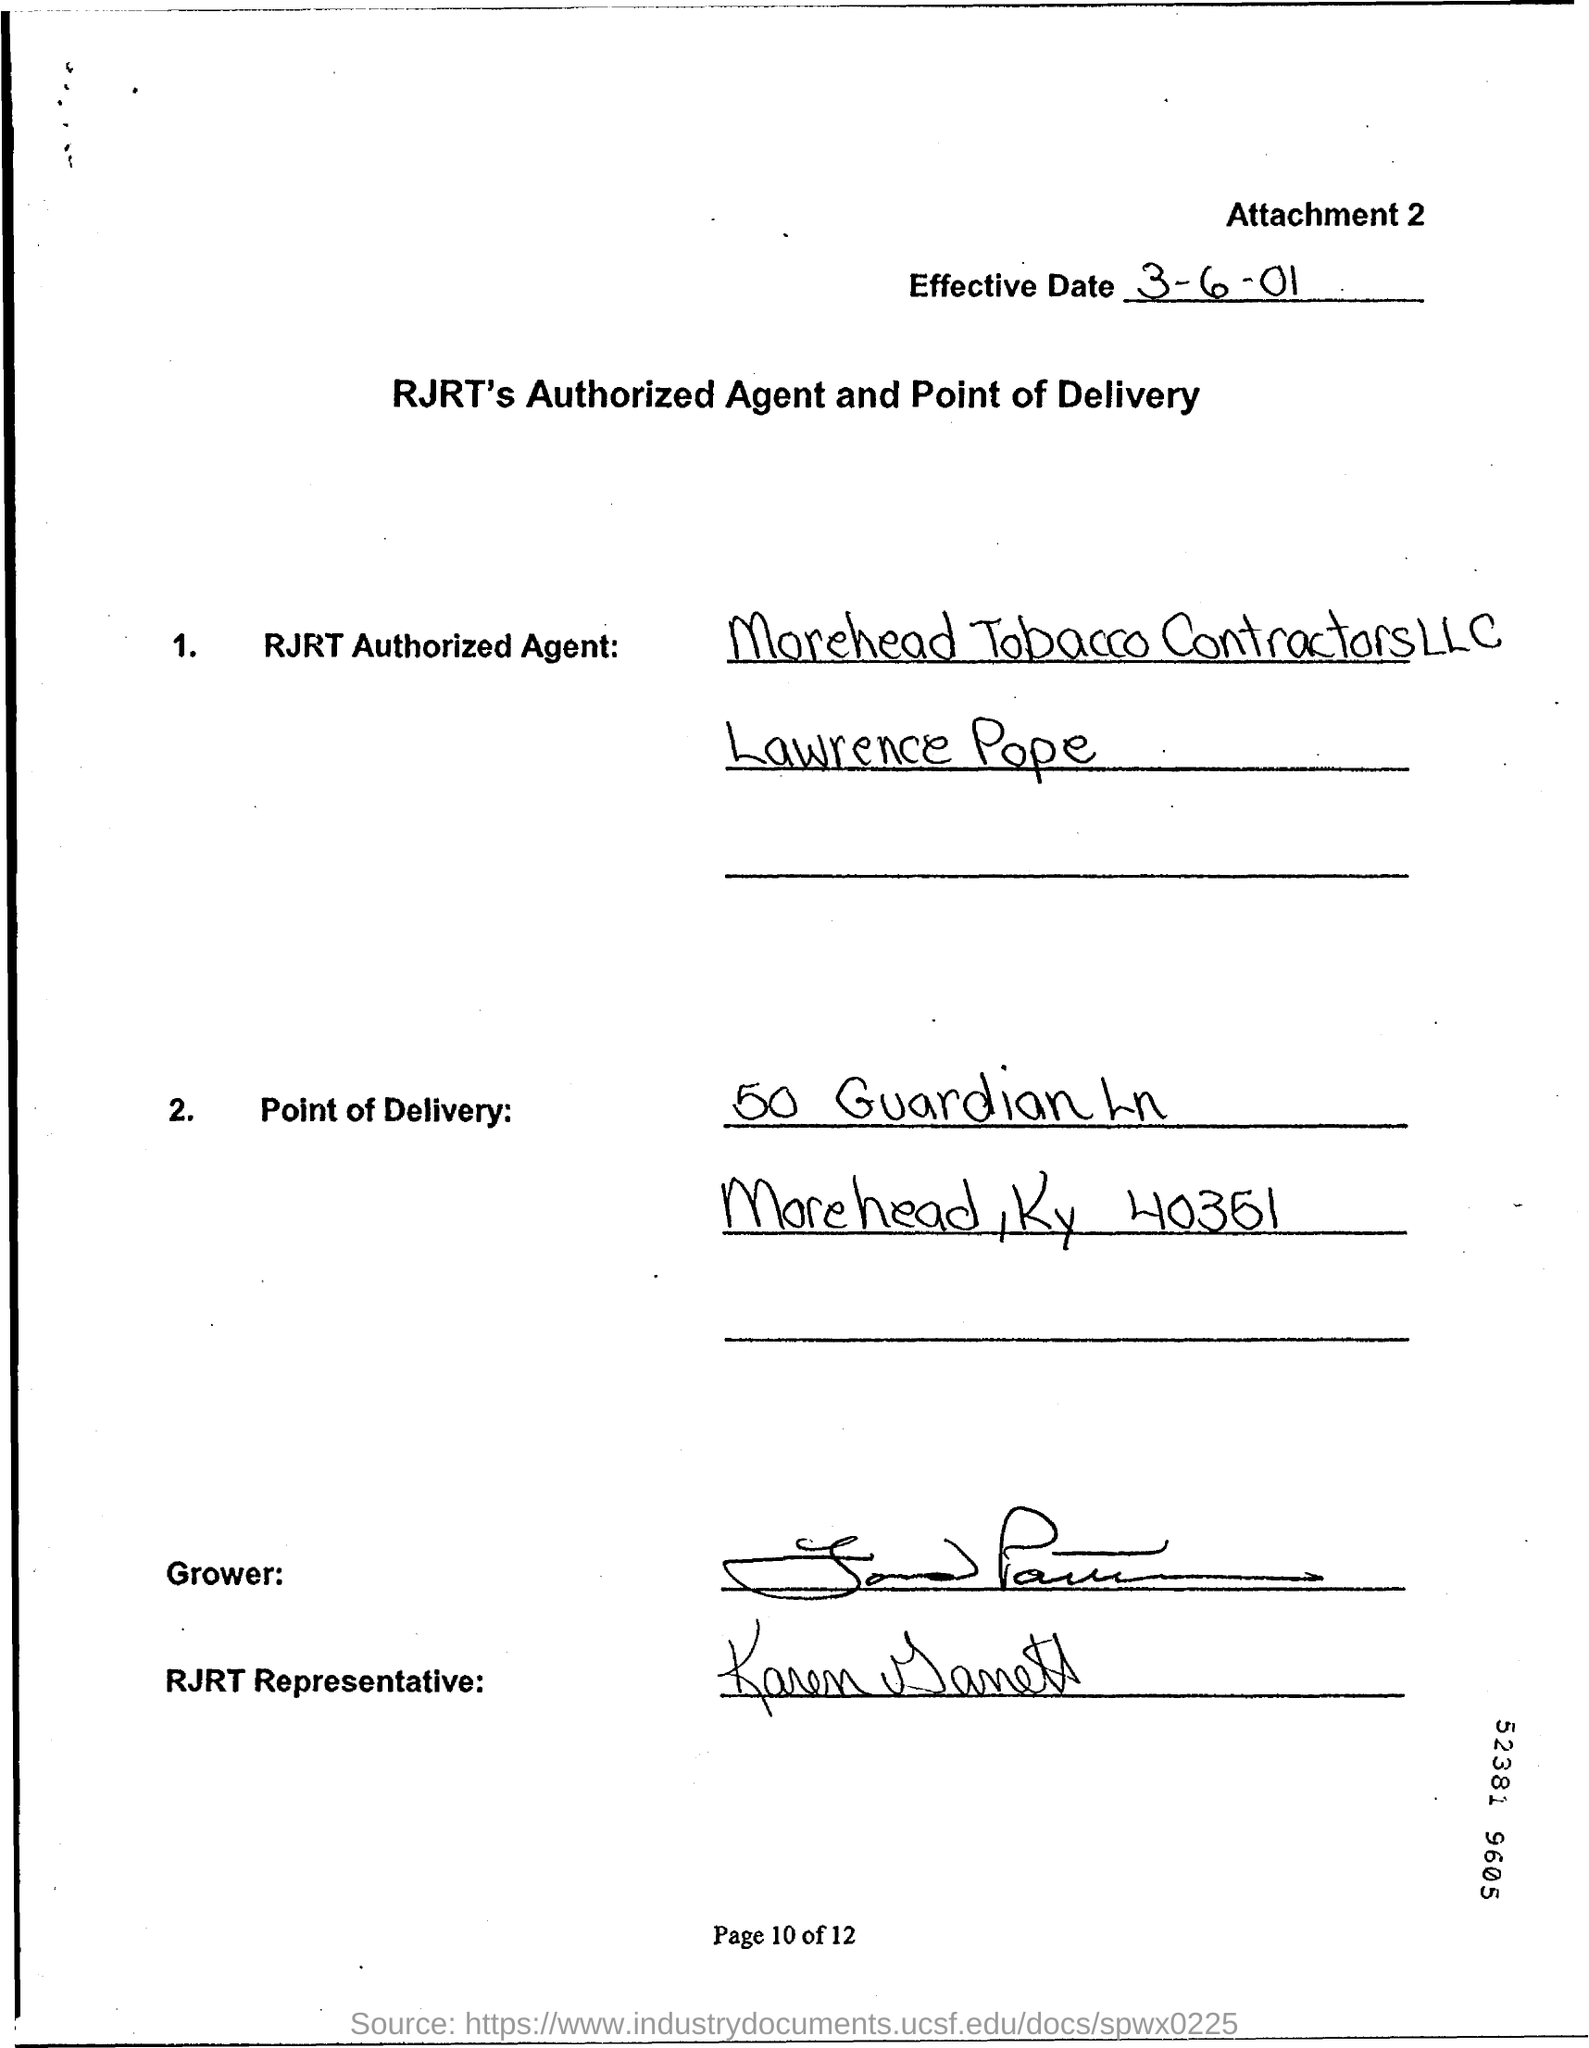What is the Effective Date?
Provide a short and direct response. Third of june 2001. 